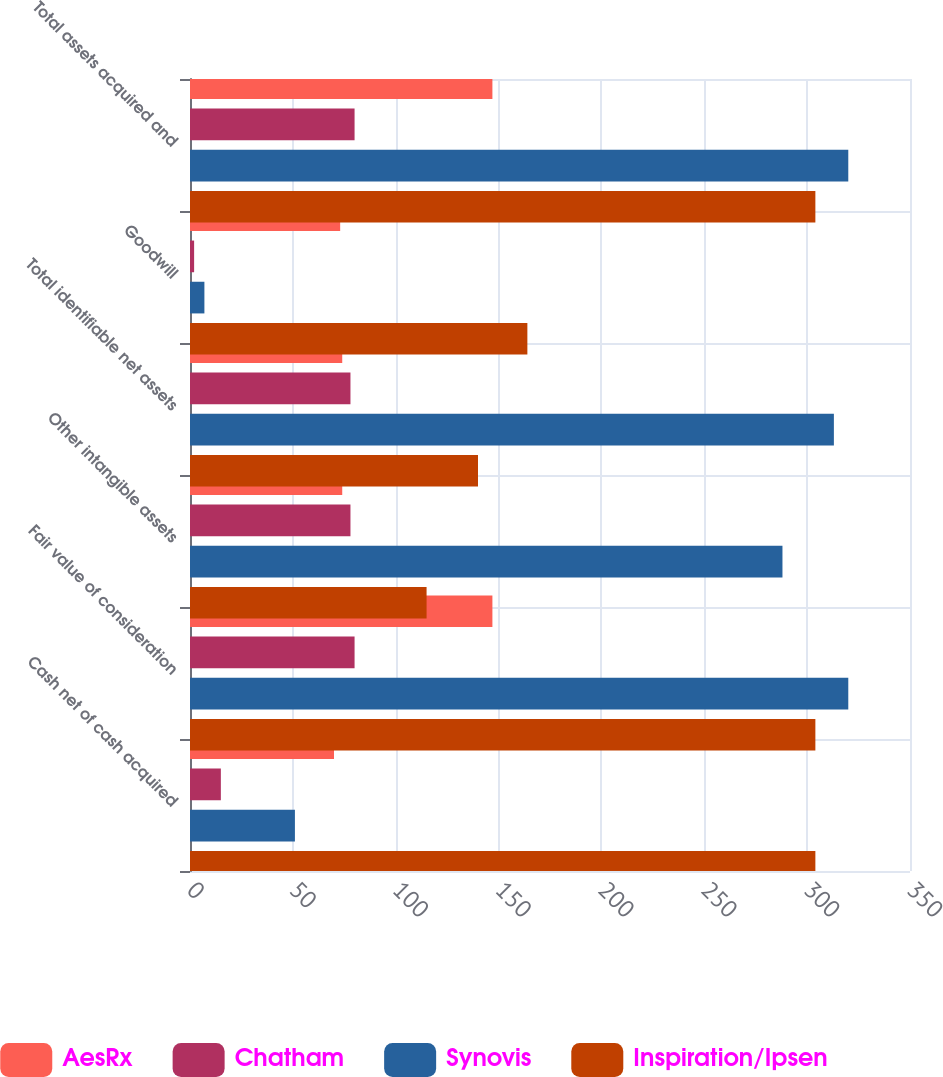Convert chart to OTSL. <chart><loc_0><loc_0><loc_500><loc_500><stacked_bar_chart><ecel><fcel>Cash net of cash acquired<fcel>Fair value of consideration<fcel>Other intangible assets<fcel>Total identifiable net assets<fcel>Goodwill<fcel>Total assets acquired and<nl><fcel>AesRx<fcel>70<fcel>147<fcel>74<fcel>74<fcel>73<fcel>147<nl><fcel>Chatham<fcel>15<fcel>80<fcel>78<fcel>78<fcel>2<fcel>80<nl><fcel>Synovis<fcel>51<fcel>320<fcel>288<fcel>313<fcel>7<fcel>320<nl><fcel>Inspiration/Ipsen<fcel>304<fcel>304<fcel>115<fcel>140<fcel>164<fcel>304<nl></chart> 